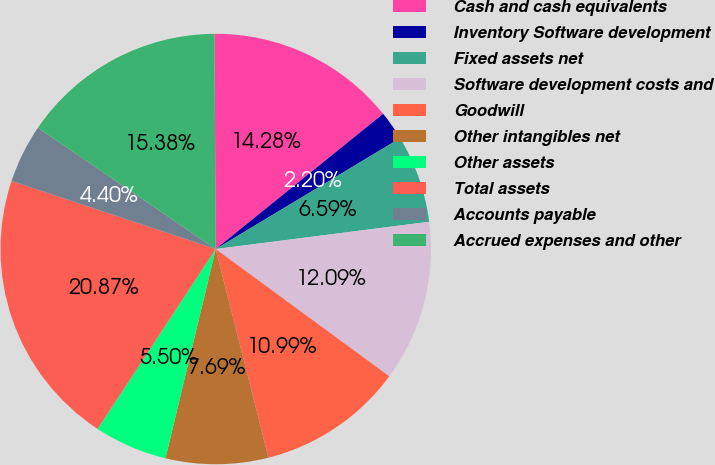Convert chart to OTSL. <chart><loc_0><loc_0><loc_500><loc_500><pie_chart><fcel>Cash and cash equivalents<fcel>Inventory Software development<fcel>Fixed assets net<fcel>Software development costs and<fcel>Goodwill<fcel>Other intangibles net<fcel>Other assets<fcel>Total assets<fcel>Accounts payable<fcel>Accrued expenses and other<nl><fcel>14.28%<fcel>2.2%<fcel>6.59%<fcel>12.09%<fcel>10.99%<fcel>7.69%<fcel>5.5%<fcel>20.87%<fcel>4.4%<fcel>15.38%<nl></chart> 